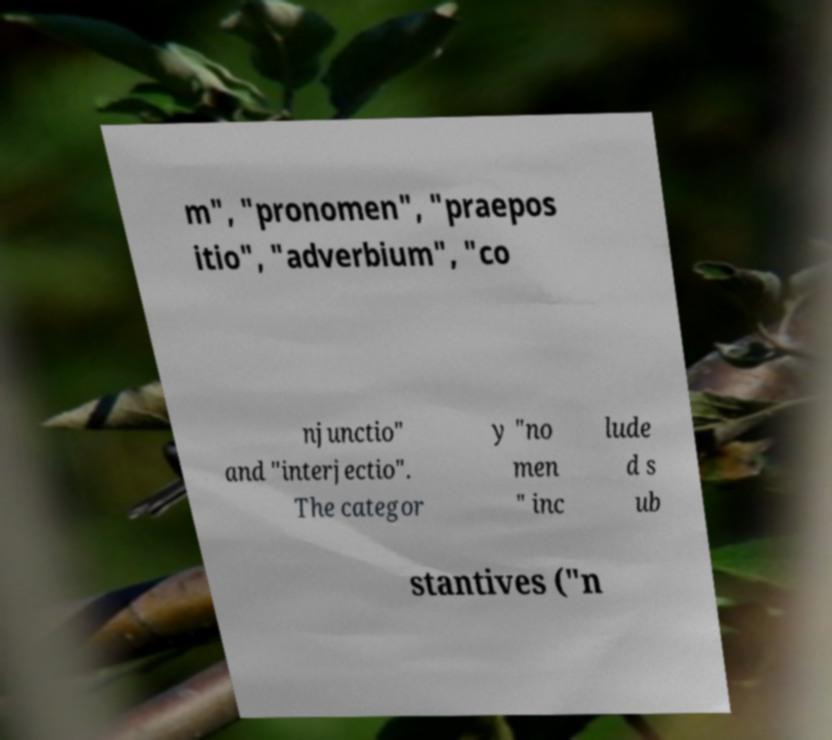Can you accurately transcribe the text from the provided image for me? m", "pronomen", "praepos itio", "adverbium", "co njunctio" and "interjectio". The categor y "no men " inc lude d s ub stantives ("n 